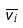<formula> <loc_0><loc_0><loc_500><loc_500>\overline { v _ { i } }</formula> 